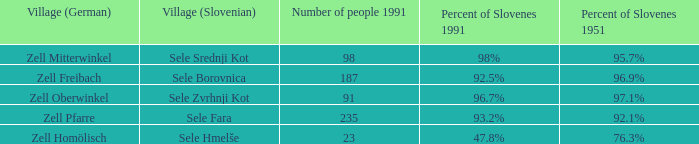Provide me with the names of all the villages (German) that has 76.3% of Slovenes in 1951. Zell Homölisch. Could you parse the entire table as a dict? {'header': ['Village (German)', 'Village (Slovenian)', 'Number of people 1991', 'Percent of Slovenes 1991', 'Percent of Slovenes 1951'], 'rows': [['Zell Mitterwinkel', 'Sele Srednji Kot', '98', '98%', '95.7%'], ['Zell Freibach', 'Sele Borovnica', '187', '92.5%', '96.9%'], ['Zell Oberwinkel', 'Sele Zvrhnji Kot', '91', '96.7%', '97.1%'], ['Zell Pfarre', 'Sele Fara', '235', '93.2%', '92.1%'], ['Zell Homölisch', 'Sele Hmelše', '23', '47.8%', '76.3%']]} 